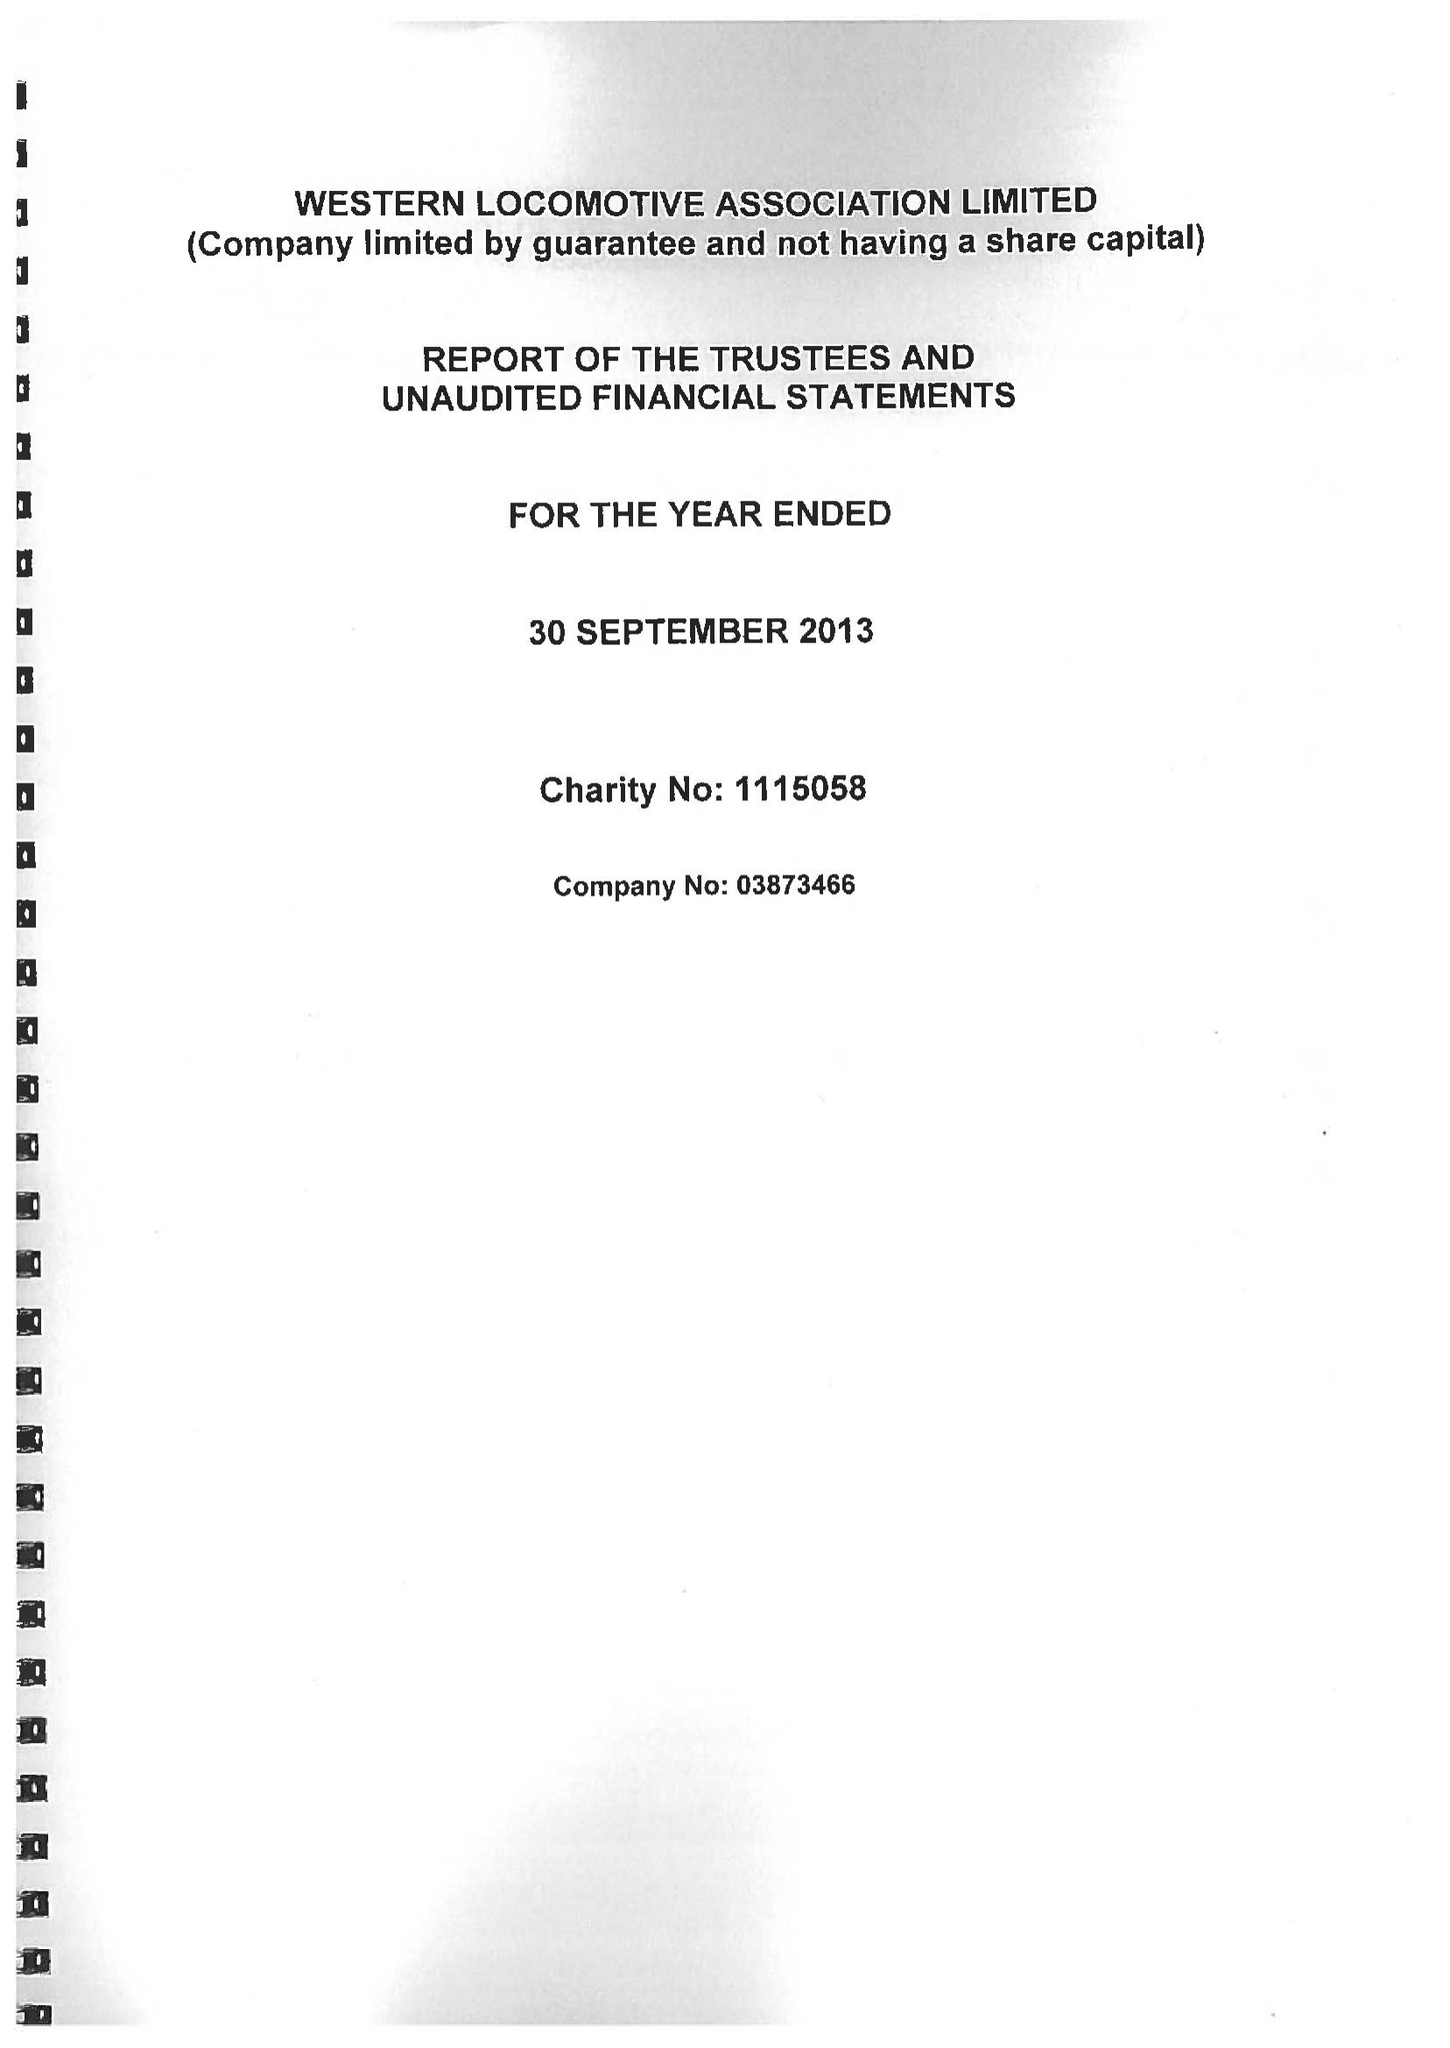What is the value for the income_annually_in_british_pounds?
Answer the question using a single word or phrase. 45077.00 